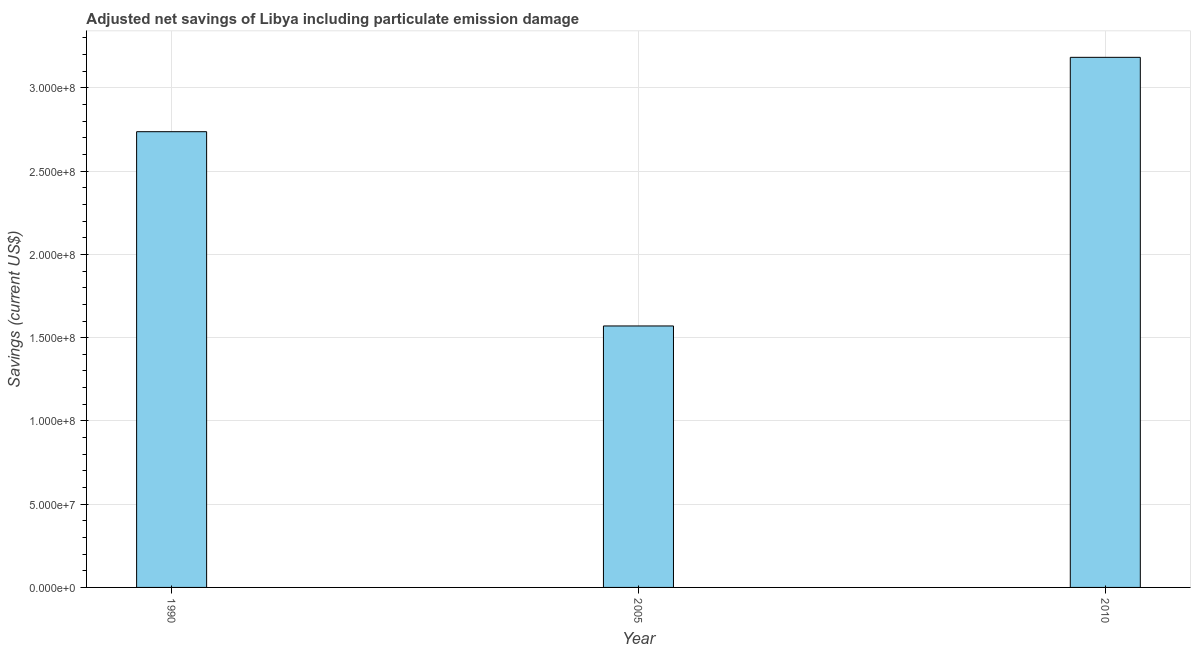What is the title of the graph?
Keep it short and to the point. Adjusted net savings of Libya including particulate emission damage. What is the label or title of the Y-axis?
Offer a very short reply. Savings (current US$). What is the adjusted net savings in 2010?
Ensure brevity in your answer.  3.18e+08. Across all years, what is the maximum adjusted net savings?
Your response must be concise. 3.18e+08. Across all years, what is the minimum adjusted net savings?
Your response must be concise. 1.57e+08. In which year was the adjusted net savings maximum?
Your response must be concise. 2010. In which year was the adjusted net savings minimum?
Offer a terse response. 2005. What is the sum of the adjusted net savings?
Ensure brevity in your answer.  7.49e+08. What is the difference between the adjusted net savings in 1990 and 2010?
Provide a succinct answer. -4.47e+07. What is the average adjusted net savings per year?
Your answer should be compact. 2.50e+08. What is the median adjusted net savings?
Make the answer very short. 2.74e+08. In how many years, is the adjusted net savings greater than 150000000 US$?
Ensure brevity in your answer.  3. Do a majority of the years between 1990 and 2005 (inclusive) have adjusted net savings greater than 150000000 US$?
Your answer should be very brief. Yes. What is the ratio of the adjusted net savings in 2005 to that in 2010?
Your response must be concise. 0.49. Is the adjusted net savings in 2005 less than that in 2010?
Your answer should be compact. Yes. Is the difference between the adjusted net savings in 2005 and 2010 greater than the difference between any two years?
Provide a succinct answer. Yes. What is the difference between the highest and the second highest adjusted net savings?
Give a very brief answer. 4.47e+07. What is the difference between the highest and the lowest adjusted net savings?
Provide a short and direct response. 1.61e+08. In how many years, is the adjusted net savings greater than the average adjusted net savings taken over all years?
Your answer should be compact. 2. Are all the bars in the graph horizontal?
Provide a succinct answer. No. How many years are there in the graph?
Your answer should be very brief. 3. What is the difference between two consecutive major ticks on the Y-axis?
Give a very brief answer. 5.00e+07. What is the Savings (current US$) of 1990?
Ensure brevity in your answer.  2.74e+08. What is the Savings (current US$) in 2005?
Your answer should be very brief. 1.57e+08. What is the Savings (current US$) in 2010?
Offer a terse response. 3.18e+08. What is the difference between the Savings (current US$) in 1990 and 2005?
Offer a terse response. 1.17e+08. What is the difference between the Savings (current US$) in 1990 and 2010?
Ensure brevity in your answer.  -4.47e+07. What is the difference between the Savings (current US$) in 2005 and 2010?
Make the answer very short. -1.61e+08. What is the ratio of the Savings (current US$) in 1990 to that in 2005?
Offer a terse response. 1.74. What is the ratio of the Savings (current US$) in 1990 to that in 2010?
Provide a succinct answer. 0.86. What is the ratio of the Savings (current US$) in 2005 to that in 2010?
Make the answer very short. 0.49. 